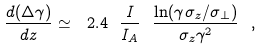Convert formula to latex. <formula><loc_0><loc_0><loc_500><loc_500>\frac { d ( \Delta \gamma ) } { d z } \simeq \ 2 . 4 \ \frac { I } { I _ { A } } \ \frac { \ln ( \gamma \sigma _ { z } / \sigma _ { \bot } ) } { \sigma _ { z } \gamma ^ { 2 } } \ ,</formula> 